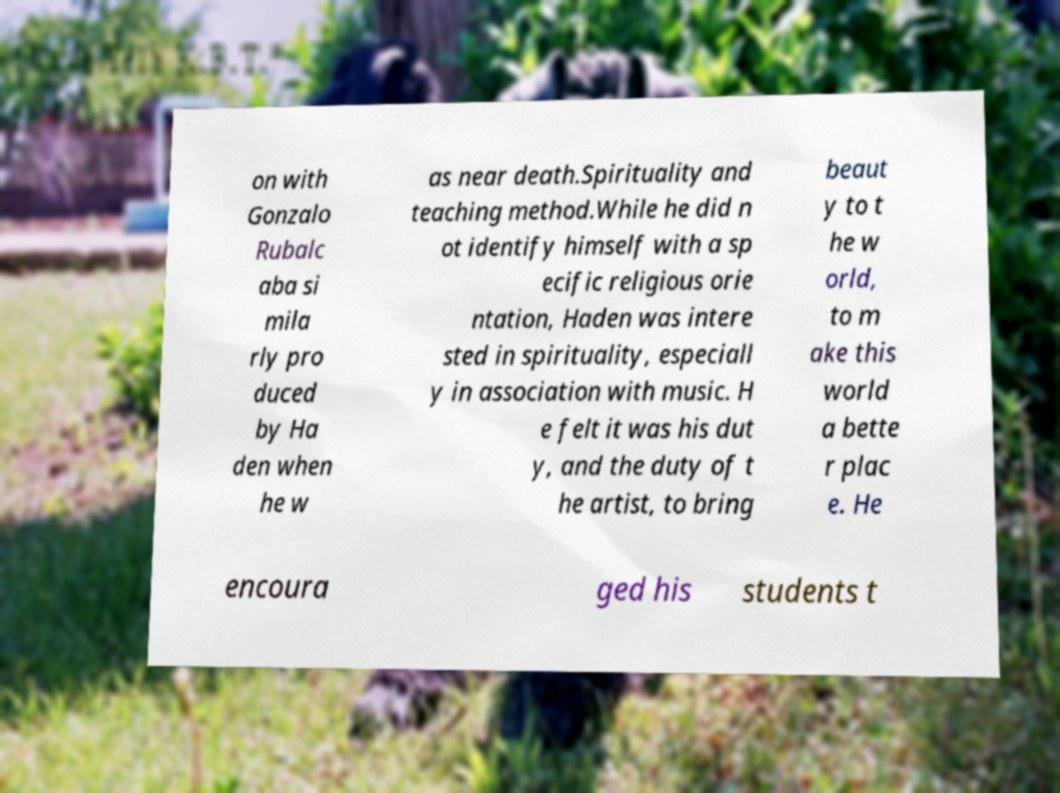Could you assist in decoding the text presented in this image and type it out clearly? on with Gonzalo Rubalc aba si mila rly pro duced by Ha den when he w as near death.Spirituality and teaching method.While he did n ot identify himself with a sp ecific religious orie ntation, Haden was intere sted in spirituality, especiall y in association with music. H e felt it was his dut y, and the duty of t he artist, to bring beaut y to t he w orld, to m ake this world a bette r plac e. He encoura ged his students t 